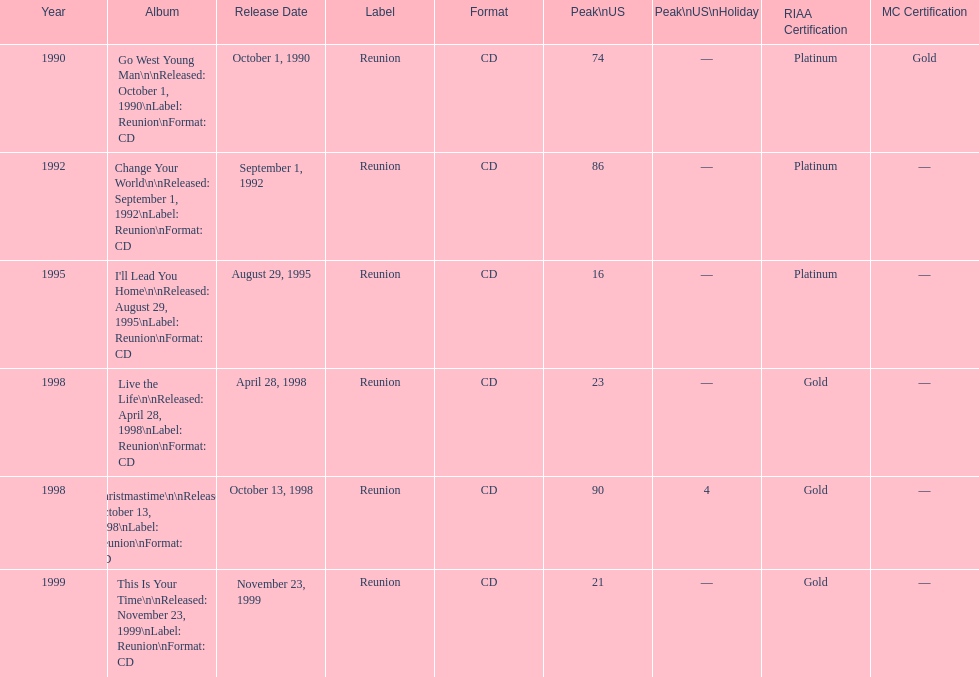What is the number of michael w smith albums that made it to the top 25 of the charts? 3. 